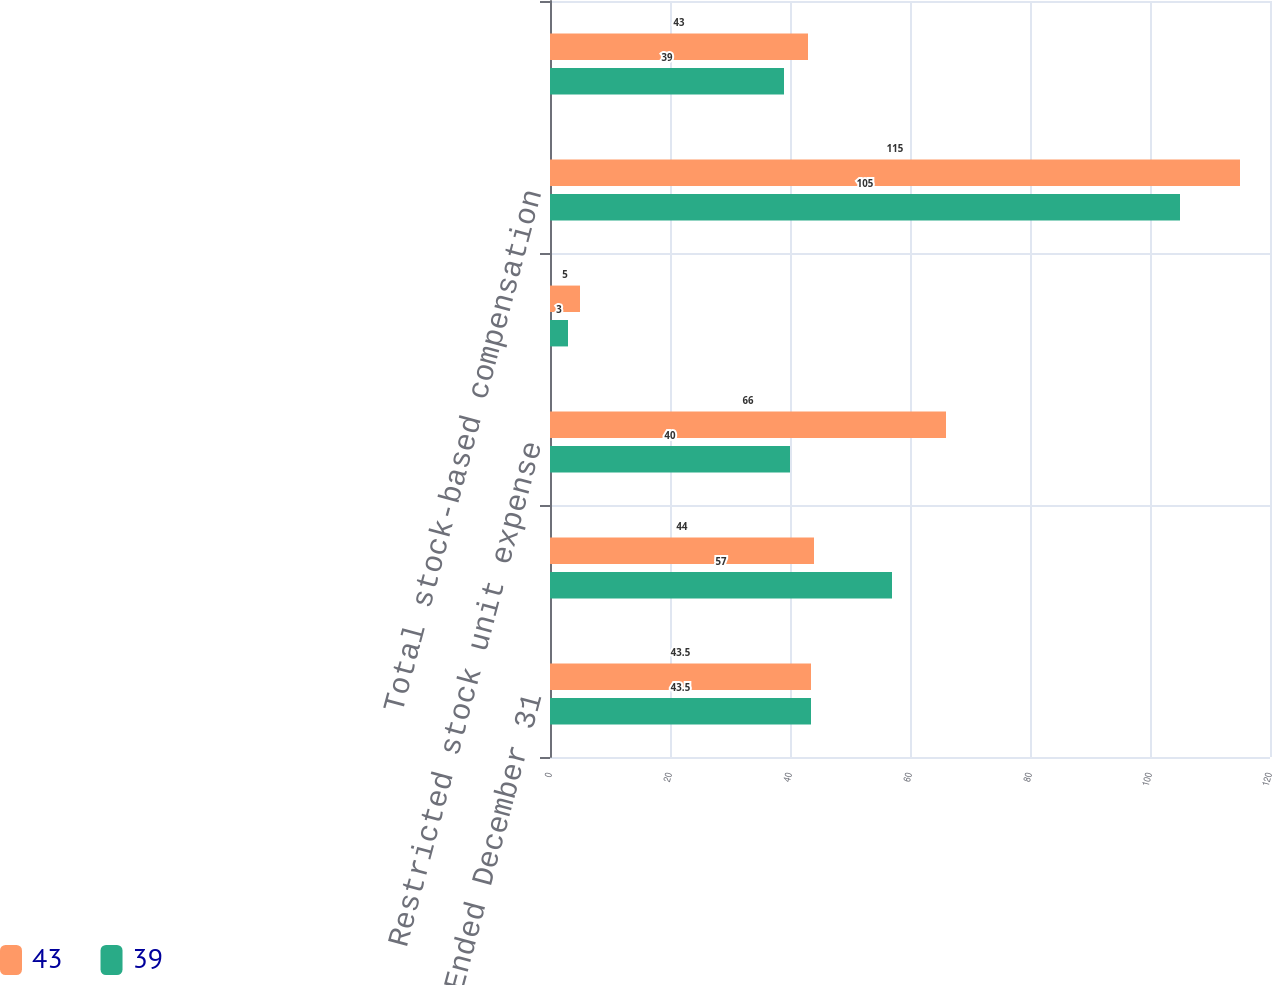Convert chart. <chart><loc_0><loc_0><loc_500><loc_500><stacked_bar_chart><ecel><fcel>Year Ended December 31<fcel>Stock option expense<fcel>Restricted stock unit expense<fcel>Employee stock purchase plan<fcel>Total stock-based compensation<fcel>Income tax benefit on<nl><fcel>43<fcel>43.5<fcel>44<fcel>66<fcel>5<fcel>115<fcel>43<nl><fcel>39<fcel>43.5<fcel>57<fcel>40<fcel>3<fcel>105<fcel>39<nl></chart> 